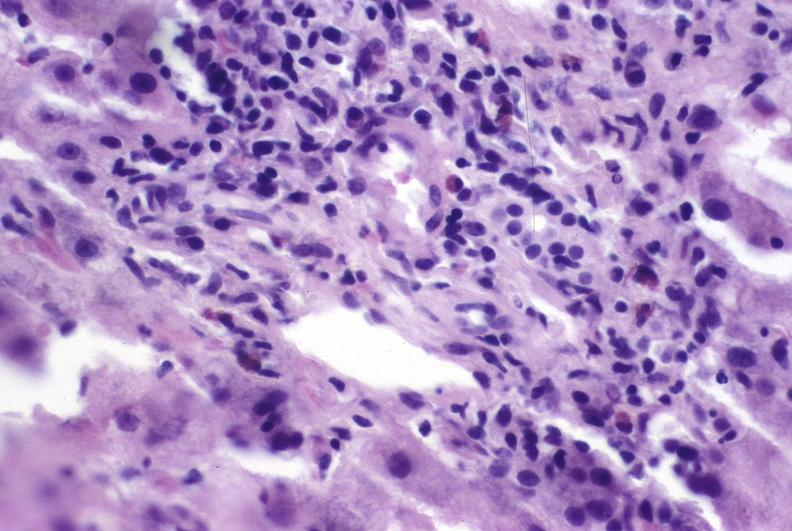s hepatobiliary present?
Answer the question using a single word or phrase. Yes 